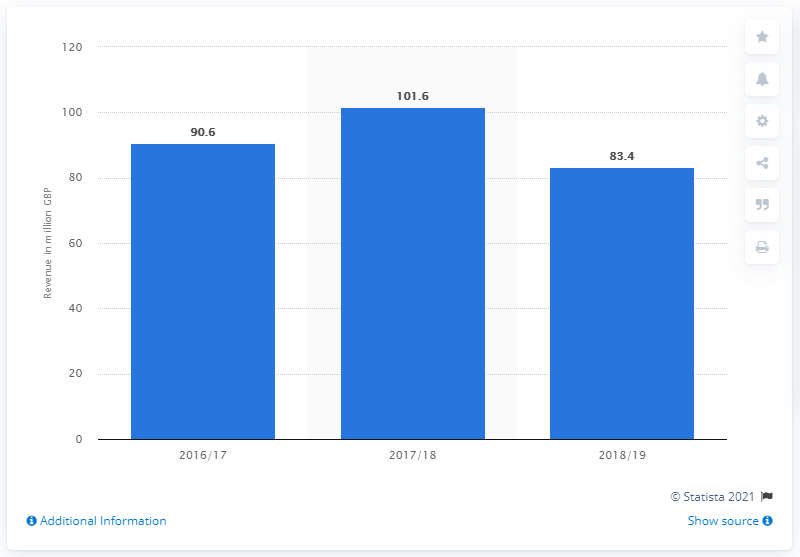Indicate a few pertinent items in this graphic. Celtic FC's revenue in the 2018/19 season was 101.6 million British Pounds. 